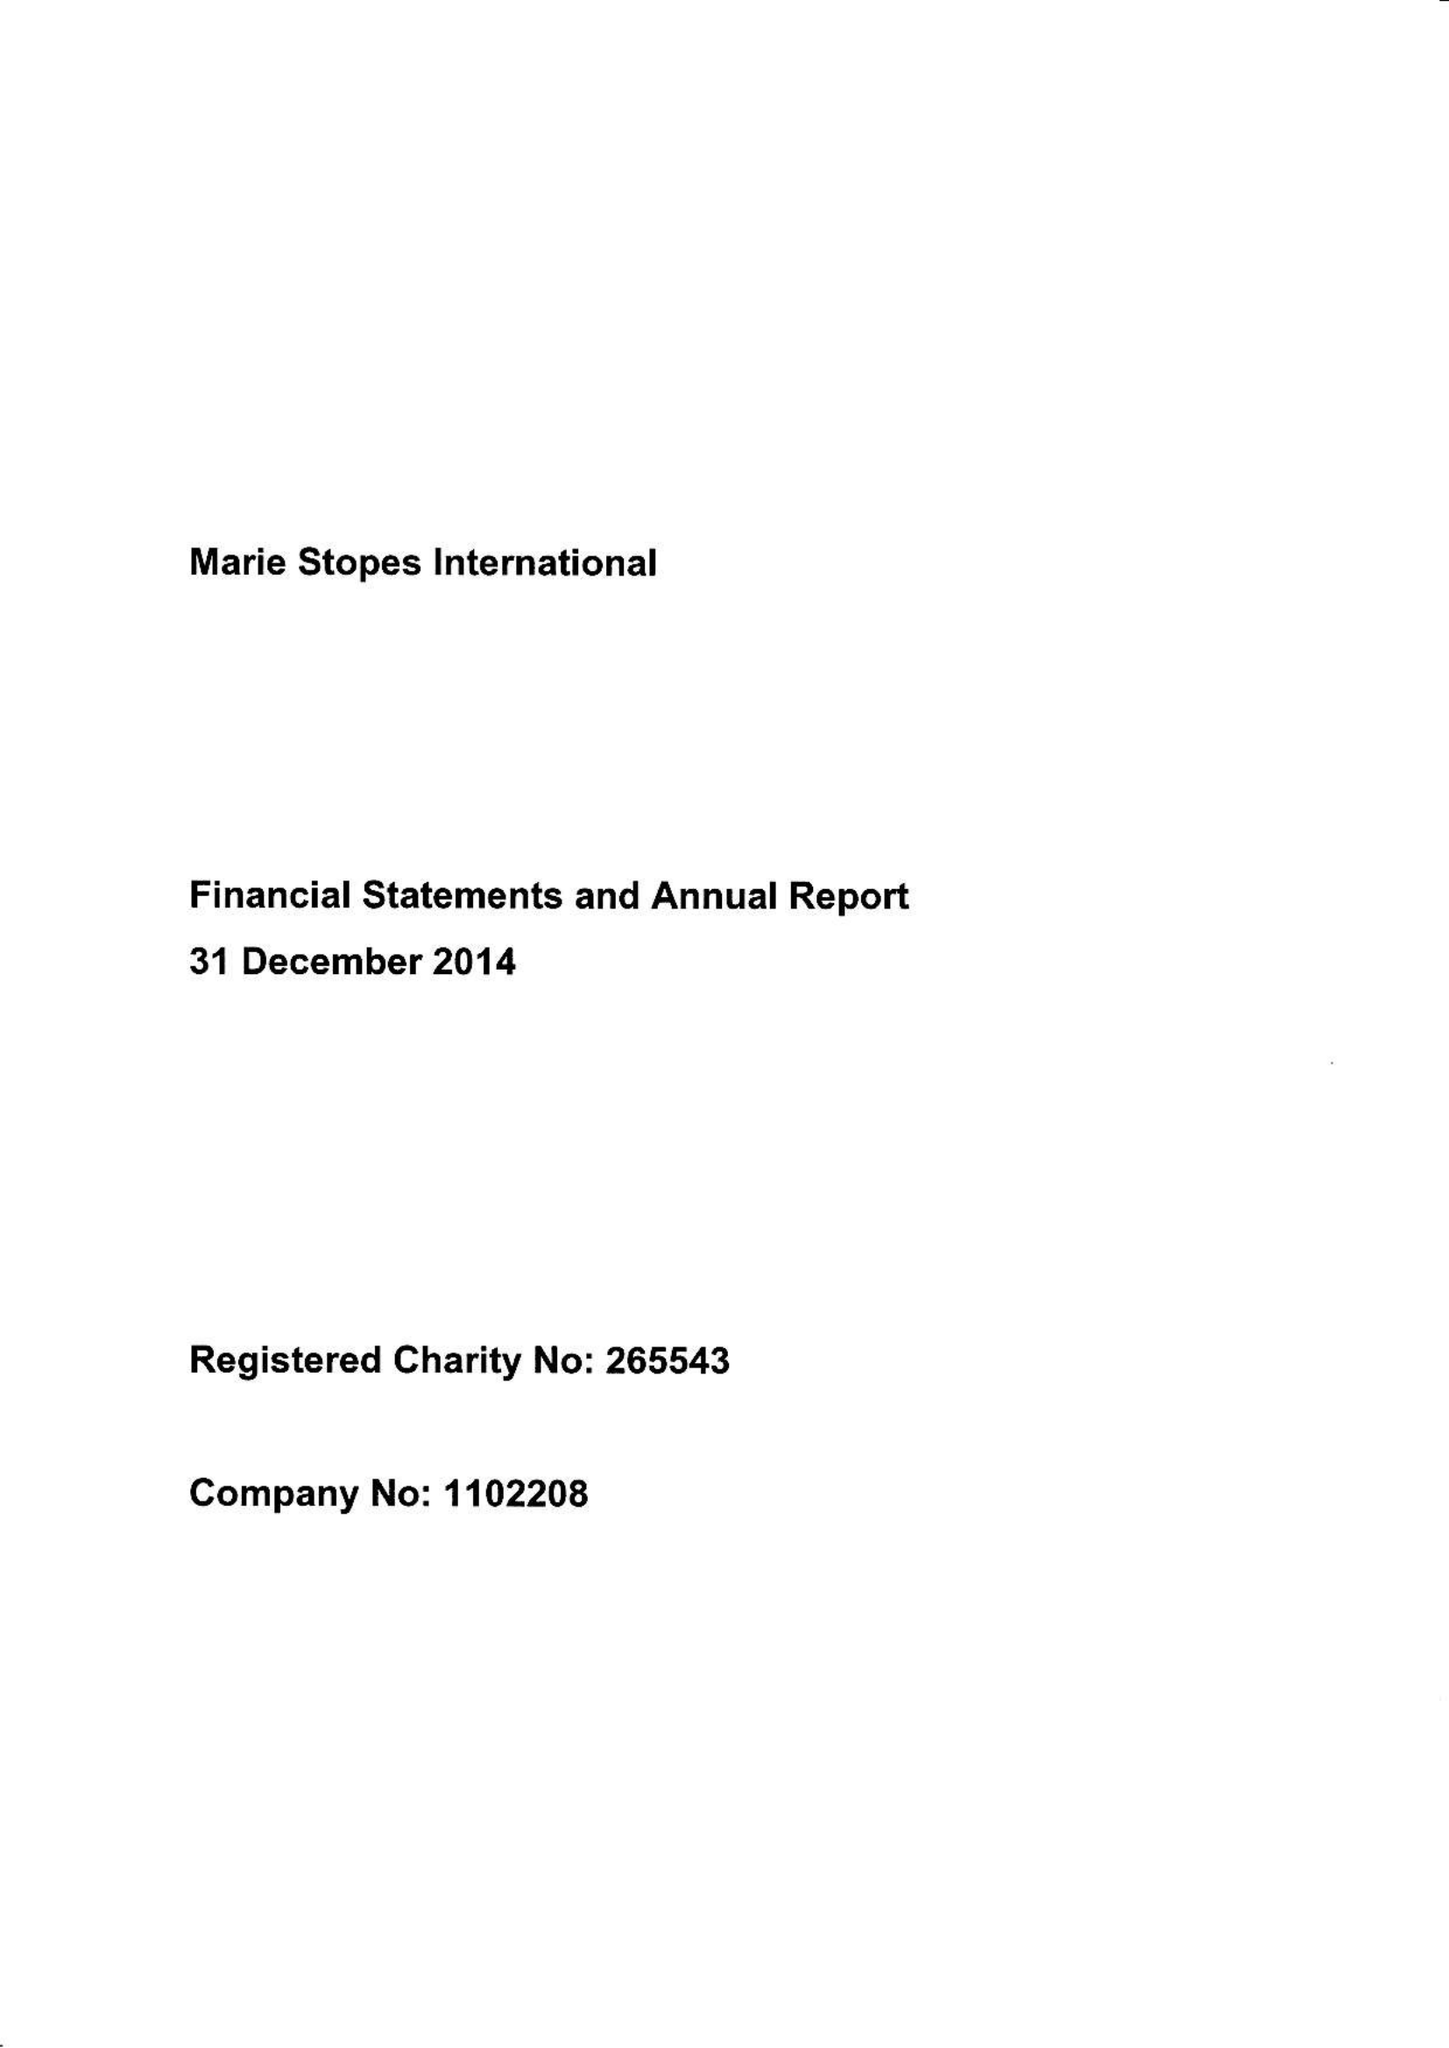What is the value for the spending_annually_in_british_pounds?
Answer the question using a single word or phrase. 228572000.00 